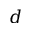Convert formula to latex. <formula><loc_0><loc_0><loc_500><loc_500>d</formula> 